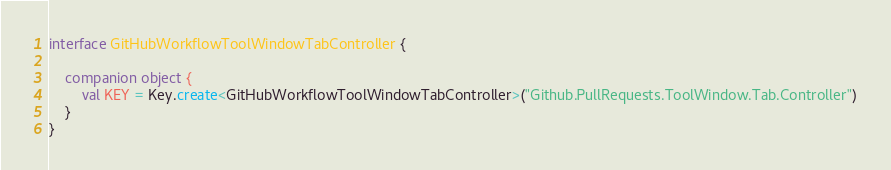Convert code to text. <code><loc_0><loc_0><loc_500><loc_500><_Kotlin_>
interface GitHubWorkflowToolWindowTabController {

    companion object {
        val KEY = Key.create<GitHubWorkflowToolWindowTabController>("Github.PullRequests.ToolWindow.Tab.Controller")
    }
}</code> 